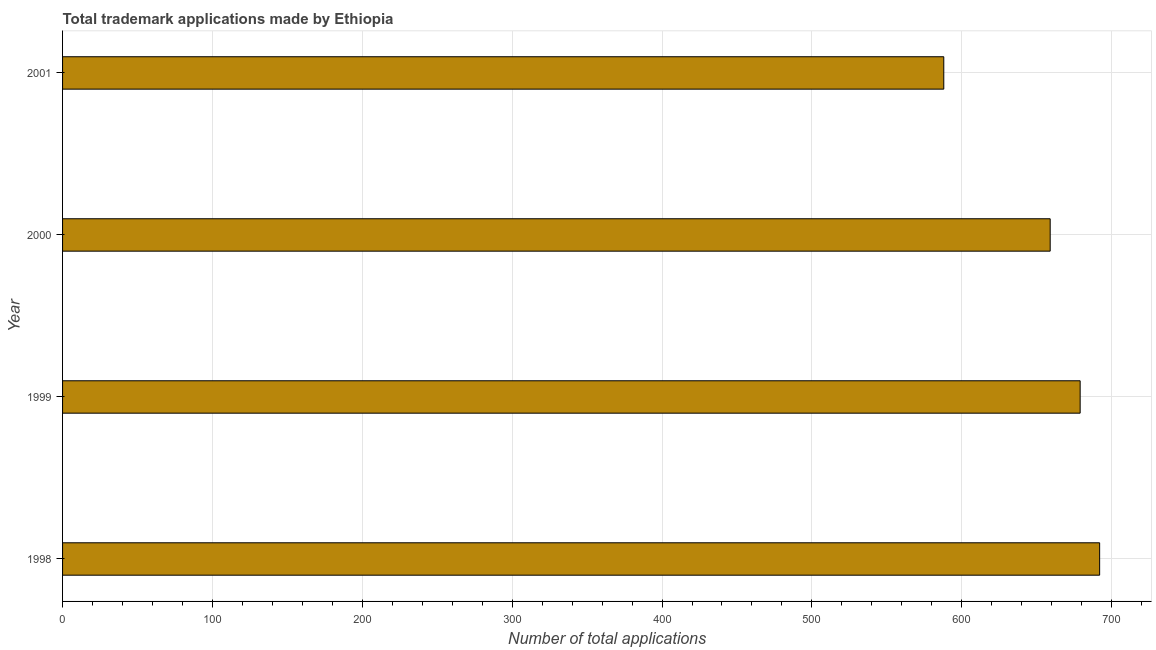Does the graph contain grids?
Ensure brevity in your answer.  Yes. What is the title of the graph?
Provide a short and direct response. Total trademark applications made by Ethiopia. What is the label or title of the X-axis?
Your answer should be very brief. Number of total applications. What is the number of trademark applications in 2001?
Provide a succinct answer. 588. Across all years, what is the maximum number of trademark applications?
Ensure brevity in your answer.  692. Across all years, what is the minimum number of trademark applications?
Offer a very short reply. 588. What is the sum of the number of trademark applications?
Provide a succinct answer. 2618. What is the difference between the number of trademark applications in 2000 and 2001?
Keep it short and to the point. 71. What is the average number of trademark applications per year?
Keep it short and to the point. 654. What is the median number of trademark applications?
Give a very brief answer. 669. Do a majority of the years between 1998 and 2000 (inclusive) have number of trademark applications greater than 120 ?
Give a very brief answer. Yes. Is the difference between the number of trademark applications in 1998 and 2000 greater than the difference between any two years?
Your answer should be very brief. No. Is the sum of the number of trademark applications in 1999 and 2001 greater than the maximum number of trademark applications across all years?
Your answer should be very brief. Yes. What is the difference between the highest and the lowest number of trademark applications?
Keep it short and to the point. 104. How many bars are there?
Offer a very short reply. 4. Are all the bars in the graph horizontal?
Keep it short and to the point. Yes. How many years are there in the graph?
Provide a succinct answer. 4. Are the values on the major ticks of X-axis written in scientific E-notation?
Give a very brief answer. No. What is the Number of total applications of 1998?
Keep it short and to the point. 692. What is the Number of total applications in 1999?
Your response must be concise. 679. What is the Number of total applications in 2000?
Keep it short and to the point. 659. What is the Number of total applications in 2001?
Offer a terse response. 588. What is the difference between the Number of total applications in 1998 and 2000?
Your response must be concise. 33. What is the difference between the Number of total applications in 1998 and 2001?
Provide a short and direct response. 104. What is the difference between the Number of total applications in 1999 and 2000?
Provide a succinct answer. 20. What is the difference between the Number of total applications in 1999 and 2001?
Make the answer very short. 91. What is the difference between the Number of total applications in 2000 and 2001?
Ensure brevity in your answer.  71. What is the ratio of the Number of total applications in 1998 to that in 2000?
Provide a short and direct response. 1.05. What is the ratio of the Number of total applications in 1998 to that in 2001?
Provide a succinct answer. 1.18. What is the ratio of the Number of total applications in 1999 to that in 2000?
Provide a succinct answer. 1.03. What is the ratio of the Number of total applications in 1999 to that in 2001?
Your answer should be very brief. 1.16. What is the ratio of the Number of total applications in 2000 to that in 2001?
Keep it short and to the point. 1.12. 